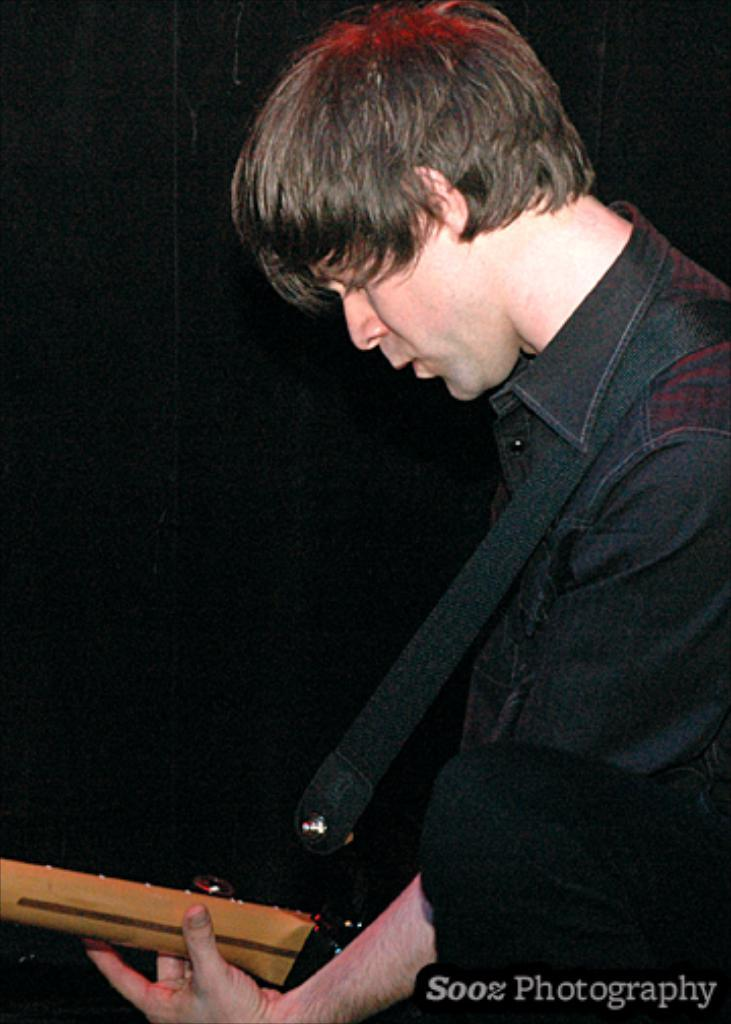What is the main subject of the image? The main subject of the image is a person standing in the front. What is the person holding in his hand? The person is holding a musical instrument in his hand. What type of appliance is the person wishing for in the image? There is no appliance or wish mentioned in the image; it only shows a person holding a musical instrument. 